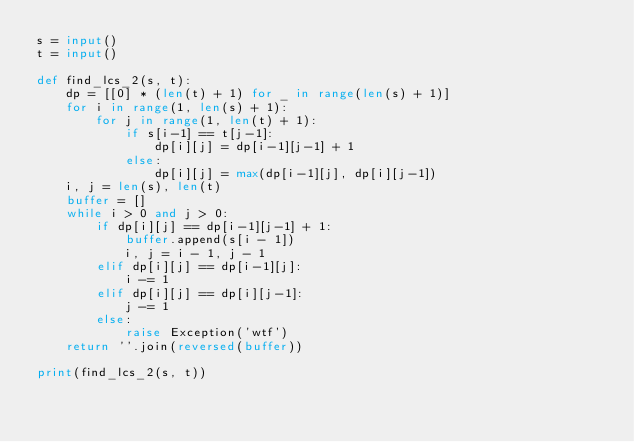<code> <loc_0><loc_0><loc_500><loc_500><_Python_>s = input()
t = input()

def find_lcs_2(s, t):
    dp = [[0] * (len(t) + 1) for _ in range(len(s) + 1)]
    for i in range(1, len(s) + 1):
        for j in range(1, len(t) + 1):
            if s[i-1] == t[j-1]:
                dp[i][j] = dp[i-1][j-1] + 1
            else:
                dp[i][j] = max(dp[i-1][j], dp[i][j-1])
    i, j = len(s), len(t)
    buffer = []
    while i > 0 and j > 0:
        if dp[i][j] == dp[i-1][j-1] + 1:
            buffer.append(s[i - 1])
            i, j = i - 1, j - 1
        elif dp[i][j] == dp[i-1][j]:
            i -= 1
        elif dp[i][j] == dp[i][j-1]:
            j -= 1
        else:
            raise Exception('wtf')
    return ''.join(reversed(buffer))
 
print(find_lcs_2(s, t))
</code> 